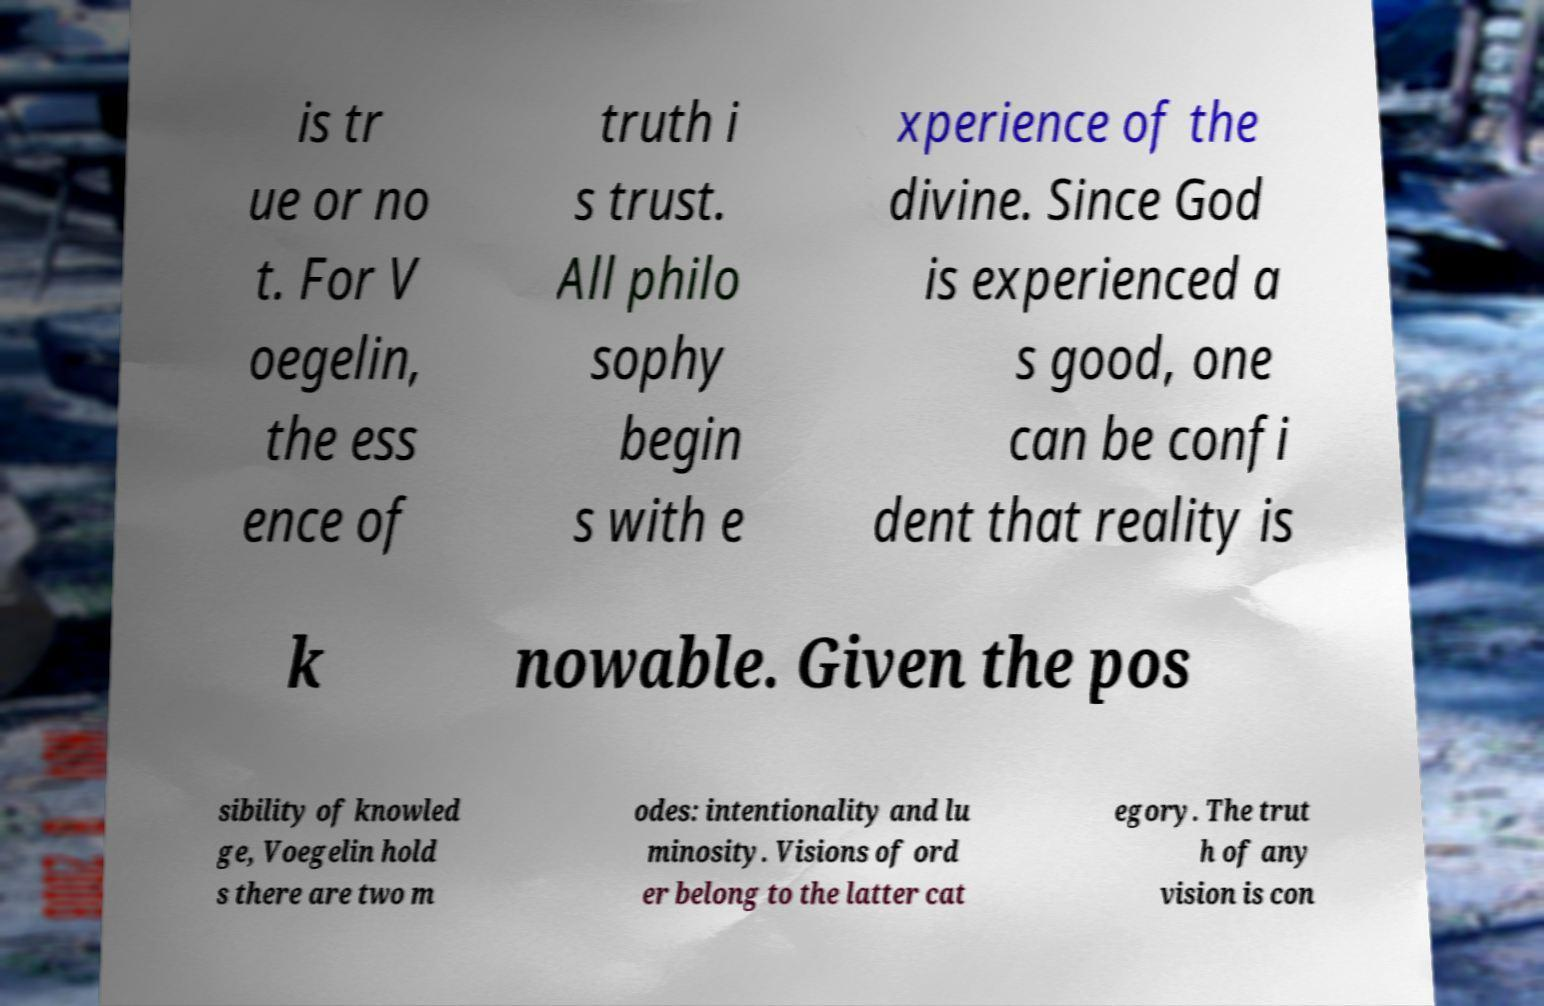Please identify and transcribe the text found in this image. is tr ue or no t. For V oegelin, the ess ence of truth i s trust. All philo sophy begin s with e xperience of the divine. Since God is experienced a s good, one can be confi dent that reality is k nowable. Given the pos sibility of knowled ge, Voegelin hold s there are two m odes: intentionality and lu minosity. Visions of ord er belong to the latter cat egory. The trut h of any vision is con 